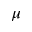Convert formula to latex. <formula><loc_0><loc_0><loc_500><loc_500>\mu</formula> 